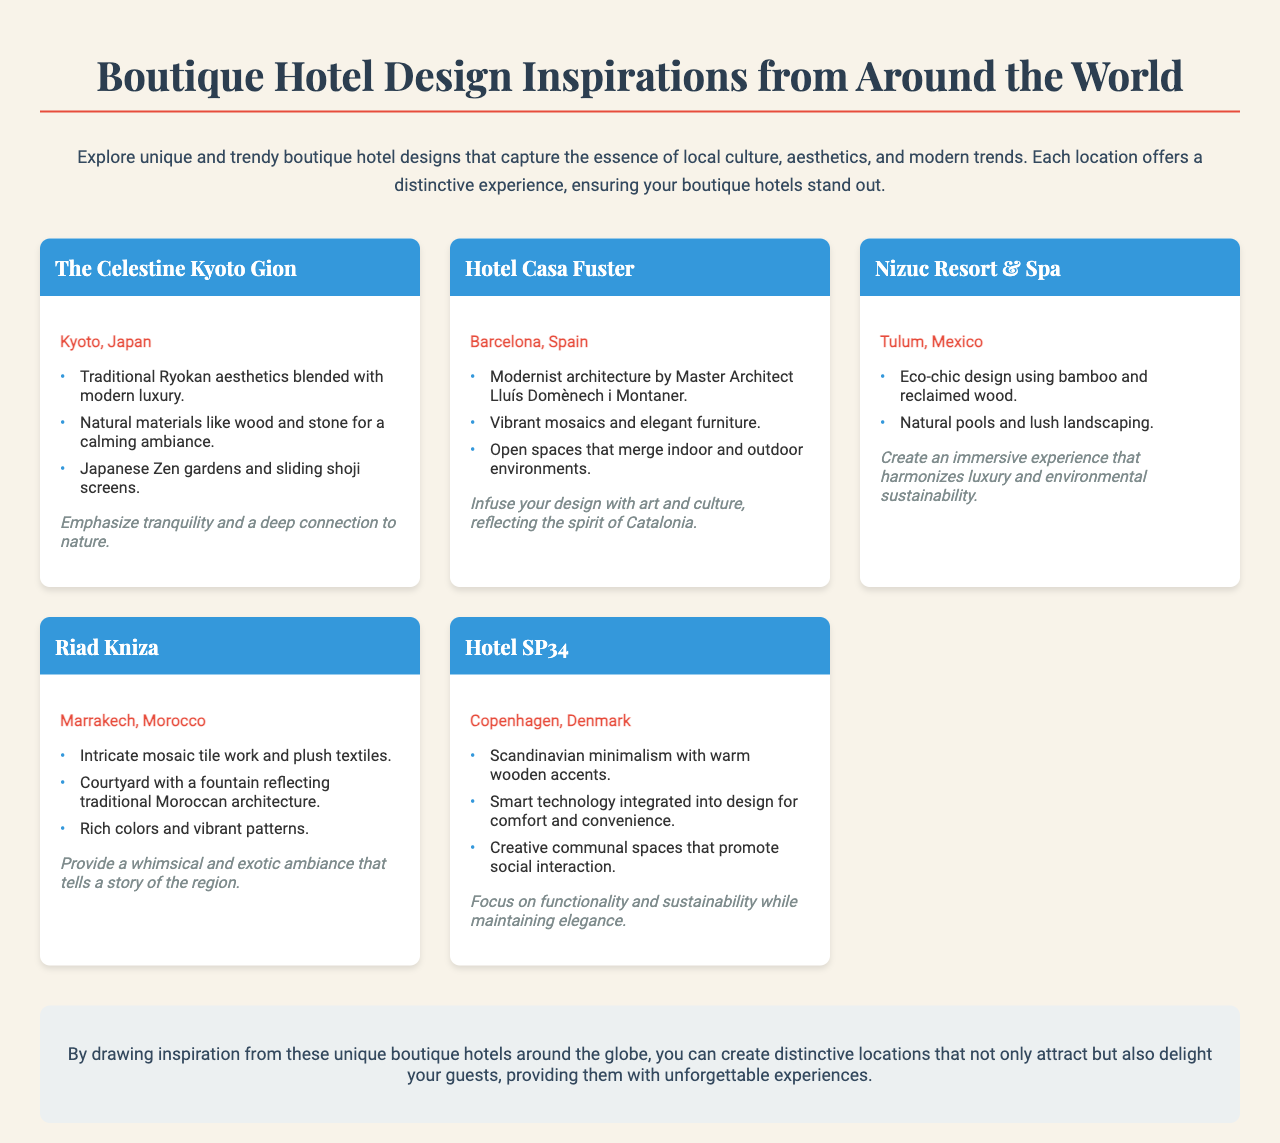what is the title of the document? The title of the document is displayed prominently at the top of the brochure.
Answer: Boutique Hotel Design Inspirations from Around the World how many hotels are featured in the brochure? The brochure lists five unique boutique hotels.
Answer: 5 which hotel is located in Kyoto, Japan? The hotel located in Kyoto, Japan is mentioned in the first hotel card.
Answer: The Celestine Kyoto Gion what design elements are emphasized in Nizuc Resort & Spa? The design elements are indicated in the hotel card for Nizuc Resort & Spa.
Answer: Eco-chic design using bamboo and reclaimed wood which city features Hotel Casa Fuster? The city where Hotel Casa Fuster is located is specified in its hotel card.
Answer: Barcelona, Spain what is the design focus of Hotel SP34? The design focus is summarized in the hotel content of Hotel SP34.
Answer: Functionality and sustainability while maintaining elegance what unique feature does Riad Kniza highlight? The unique features are described in the list of elements for Riad Kniza.
Answer: Intricate mosaic tile work and plush textiles what type of ambiance does The Celestine Kyoto Gion aim to provide? The desired ambiance for The Celestine Kyoto Gion is outlined in the inspiration section.
Answer: Tranquility and a deep connection to nature 